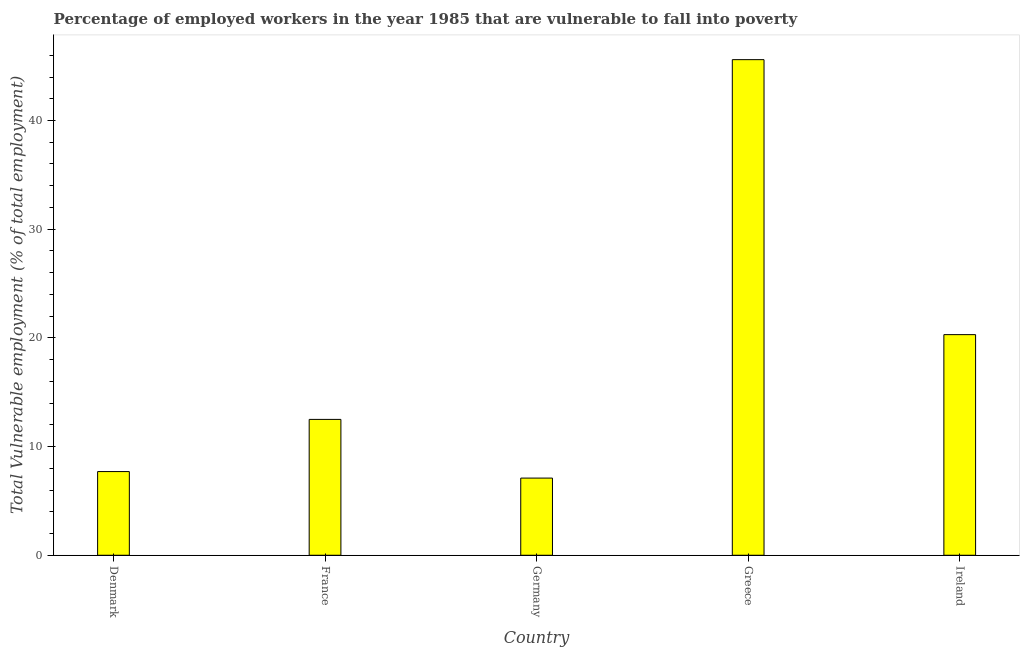Does the graph contain any zero values?
Your answer should be very brief. No. What is the title of the graph?
Your answer should be compact. Percentage of employed workers in the year 1985 that are vulnerable to fall into poverty. What is the label or title of the X-axis?
Offer a terse response. Country. What is the label or title of the Y-axis?
Offer a terse response. Total Vulnerable employment (% of total employment). What is the total vulnerable employment in Greece?
Provide a short and direct response. 45.6. Across all countries, what is the maximum total vulnerable employment?
Your answer should be very brief. 45.6. Across all countries, what is the minimum total vulnerable employment?
Your response must be concise. 7.1. In which country was the total vulnerable employment maximum?
Give a very brief answer. Greece. In which country was the total vulnerable employment minimum?
Ensure brevity in your answer.  Germany. What is the sum of the total vulnerable employment?
Your answer should be compact. 93.2. What is the average total vulnerable employment per country?
Your response must be concise. 18.64. In how many countries, is the total vulnerable employment greater than 24 %?
Offer a very short reply. 1. What is the ratio of the total vulnerable employment in France to that in Greece?
Keep it short and to the point. 0.27. Is the difference between the total vulnerable employment in Denmark and Germany greater than the difference between any two countries?
Your answer should be very brief. No. What is the difference between the highest and the second highest total vulnerable employment?
Ensure brevity in your answer.  25.3. What is the difference between the highest and the lowest total vulnerable employment?
Keep it short and to the point. 38.5. In how many countries, is the total vulnerable employment greater than the average total vulnerable employment taken over all countries?
Offer a terse response. 2. How many bars are there?
Your response must be concise. 5. Are all the bars in the graph horizontal?
Provide a short and direct response. No. What is the difference between two consecutive major ticks on the Y-axis?
Your response must be concise. 10. What is the Total Vulnerable employment (% of total employment) of Denmark?
Offer a very short reply. 7.7. What is the Total Vulnerable employment (% of total employment) in Germany?
Ensure brevity in your answer.  7.1. What is the Total Vulnerable employment (% of total employment) of Greece?
Keep it short and to the point. 45.6. What is the Total Vulnerable employment (% of total employment) in Ireland?
Keep it short and to the point. 20.3. What is the difference between the Total Vulnerable employment (% of total employment) in Denmark and France?
Make the answer very short. -4.8. What is the difference between the Total Vulnerable employment (% of total employment) in Denmark and Germany?
Provide a short and direct response. 0.6. What is the difference between the Total Vulnerable employment (% of total employment) in Denmark and Greece?
Ensure brevity in your answer.  -37.9. What is the difference between the Total Vulnerable employment (% of total employment) in France and Germany?
Offer a terse response. 5.4. What is the difference between the Total Vulnerable employment (% of total employment) in France and Greece?
Your answer should be very brief. -33.1. What is the difference between the Total Vulnerable employment (% of total employment) in France and Ireland?
Your answer should be compact. -7.8. What is the difference between the Total Vulnerable employment (% of total employment) in Germany and Greece?
Provide a short and direct response. -38.5. What is the difference between the Total Vulnerable employment (% of total employment) in Germany and Ireland?
Offer a very short reply. -13.2. What is the difference between the Total Vulnerable employment (% of total employment) in Greece and Ireland?
Offer a very short reply. 25.3. What is the ratio of the Total Vulnerable employment (% of total employment) in Denmark to that in France?
Make the answer very short. 0.62. What is the ratio of the Total Vulnerable employment (% of total employment) in Denmark to that in Germany?
Your answer should be compact. 1.08. What is the ratio of the Total Vulnerable employment (% of total employment) in Denmark to that in Greece?
Give a very brief answer. 0.17. What is the ratio of the Total Vulnerable employment (% of total employment) in Denmark to that in Ireland?
Provide a succinct answer. 0.38. What is the ratio of the Total Vulnerable employment (% of total employment) in France to that in Germany?
Offer a terse response. 1.76. What is the ratio of the Total Vulnerable employment (% of total employment) in France to that in Greece?
Your answer should be compact. 0.27. What is the ratio of the Total Vulnerable employment (% of total employment) in France to that in Ireland?
Your answer should be very brief. 0.62. What is the ratio of the Total Vulnerable employment (% of total employment) in Germany to that in Greece?
Your answer should be compact. 0.16. What is the ratio of the Total Vulnerable employment (% of total employment) in Greece to that in Ireland?
Provide a succinct answer. 2.25. 